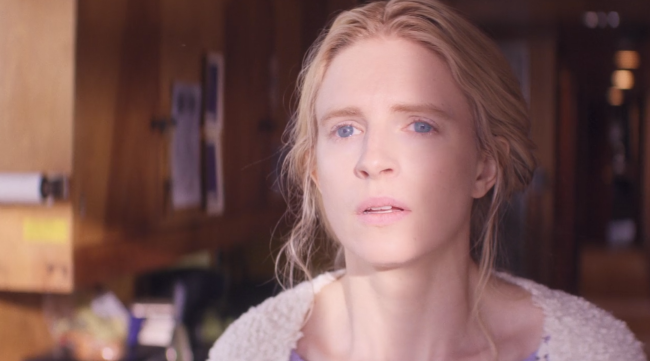What do you think this woman is thinking about? Perhaps she is reflecting on a significant event in her life. Her expression suggests a mix of emotions, possibly considering both the positive and negative aspects of what has happened recently. 